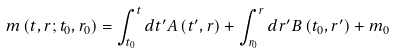<formula> <loc_0><loc_0><loc_500><loc_500>m \left ( t , r ; t _ { 0 } , r _ { 0 } \right ) = \int ^ { t } _ { t _ { 0 } } d t ^ { \prime } A \left ( t ^ { \prime } , r \right ) + \int ^ { r } _ { r _ { 0 } } d r ^ { \prime } B \left ( t _ { 0 } , r ^ { \prime } \right ) + m _ { 0 }</formula> 